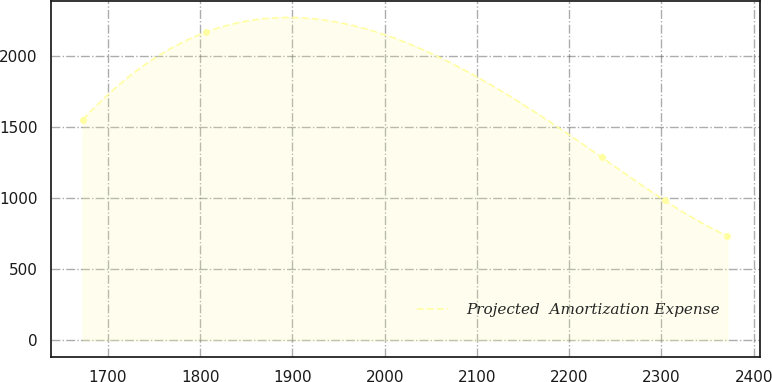Convert chart to OTSL. <chart><loc_0><loc_0><loc_500><loc_500><line_chart><ecel><fcel>Projected  Amortization Expense<nl><fcel>1672.92<fcel>1555.78<nl><fcel>1806.44<fcel>2171.45<nl><fcel>2235.2<fcel>1290.49<nl><fcel>2303.41<fcel>986.09<nl><fcel>2371.62<fcel>735.43<nl></chart> 